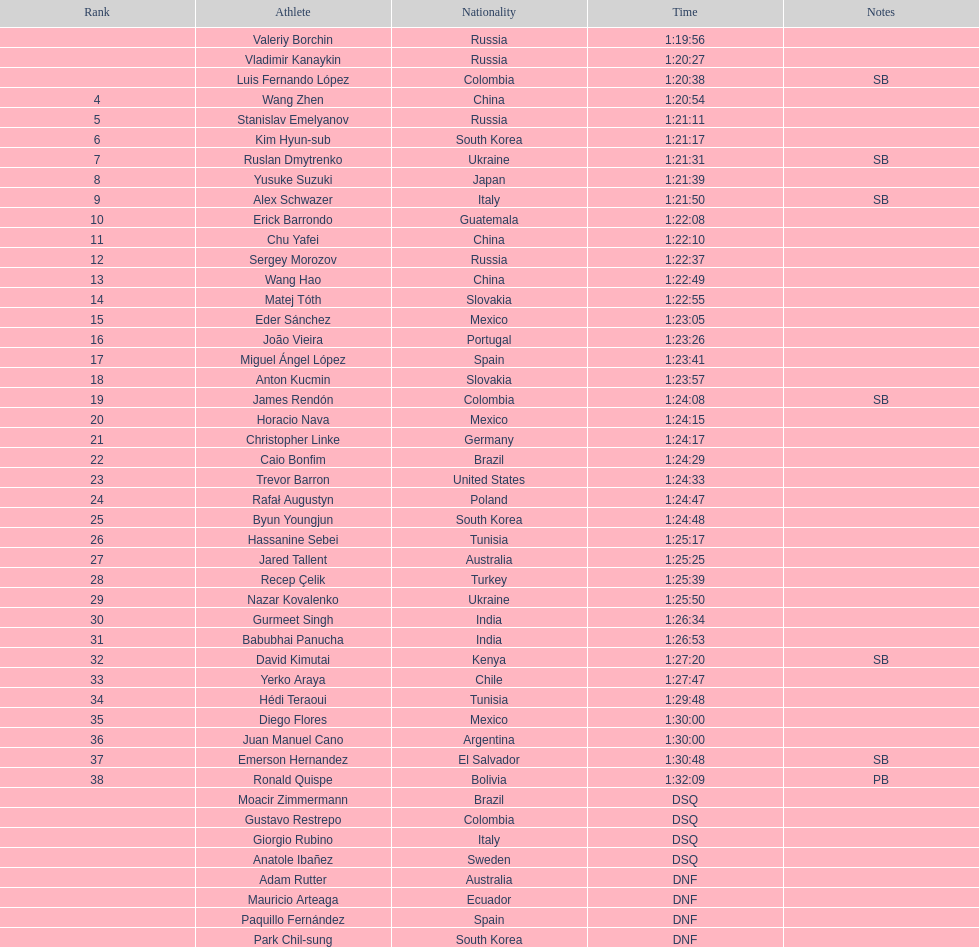What is the total count of athletes included in the rankings chart, including those classified as dsq & dnf? 46. 